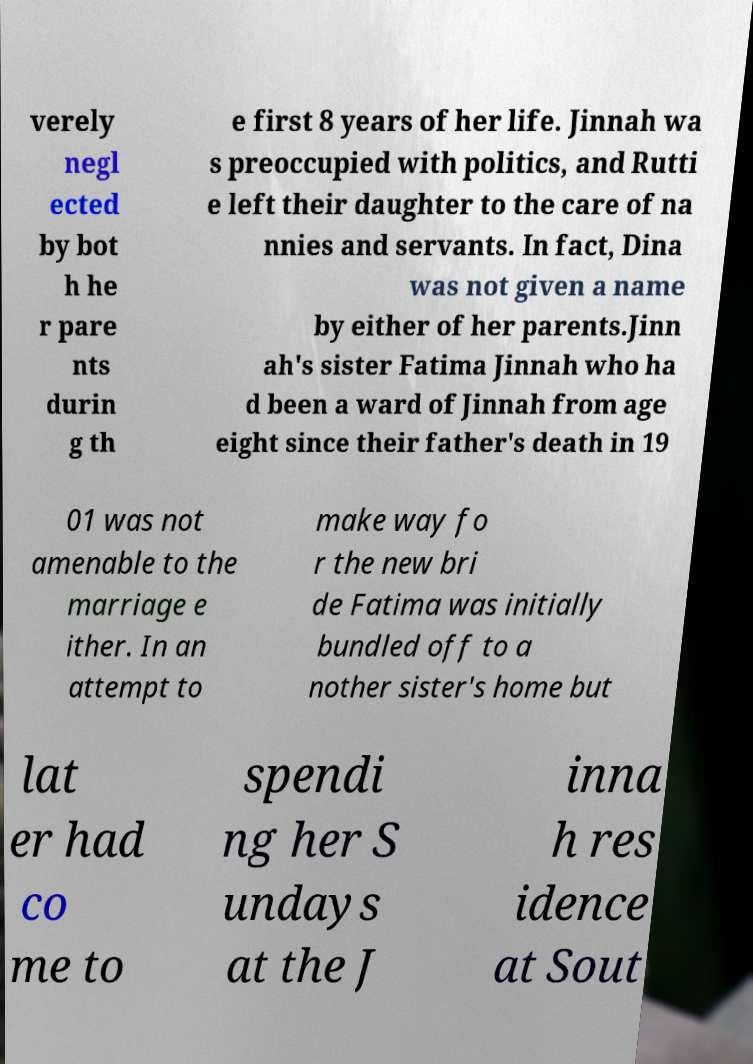Could you extract and type out the text from this image? verely negl ected by bot h he r pare nts durin g th e first 8 years of her life. Jinnah wa s preoccupied with politics, and Rutti e left their daughter to the care of na nnies and servants. In fact, Dina was not given a name by either of her parents.Jinn ah's sister Fatima Jinnah who ha d been a ward of Jinnah from age eight since their father's death in 19 01 was not amenable to the marriage e ither. In an attempt to make way fo r the new bri de Fatima was initially bundled off to a nother sister's home but lat er had co me to spendi ng her S undays at the J inna h res idence at Sout 